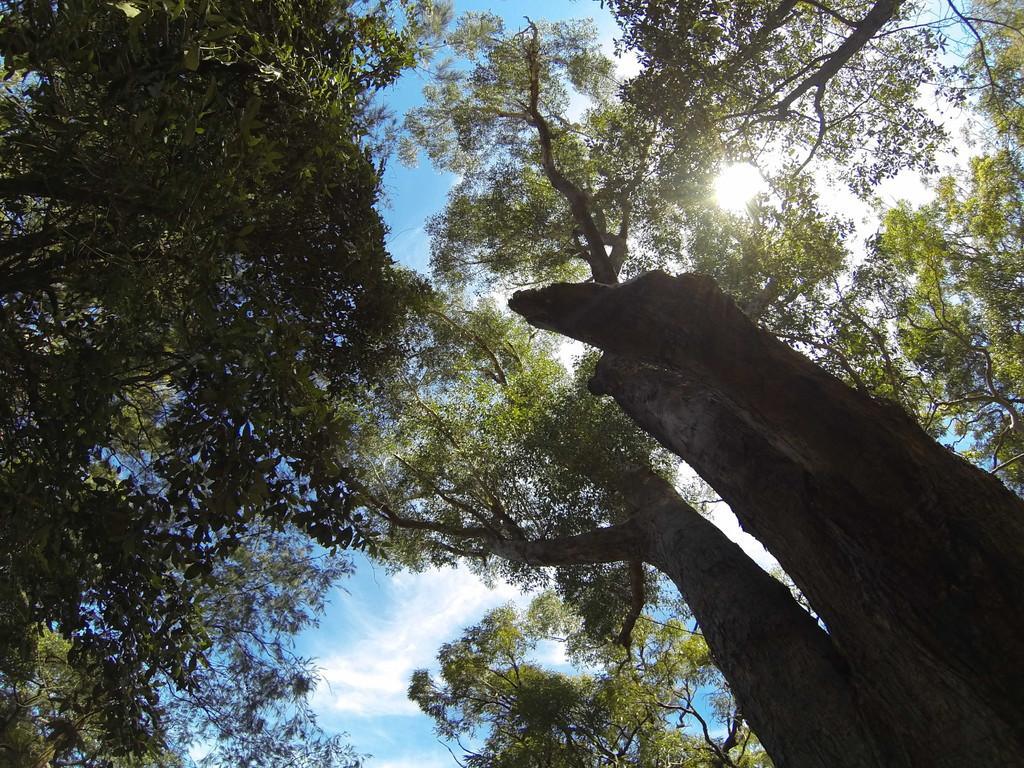Can you describe this image briefly? In this image we can see trees, sky, sun and clouds. 